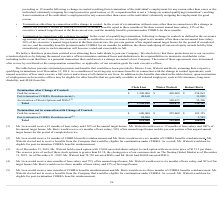From Marin Software's financial document, How many months of base salary would Mr Lien and Mr Walcott respectively receive as part of their cash severance? The document shows two values: 18 and 12. From the document: "(1) Mr. Lien would receive 18 months of base salary and 150% of his annual target bonus. Mr. Walcott would receive 12 months of b preceding or 12 mont..." Also, What percentage of their annual target bonus would Mr Lien and Mr Walcott respectively receive as part of their cash severance? The document shows two values: 150% and 100%. From the document: "Walcott would receive 12 months of base salary and 100% of his annual target bonus. Mr. Bertz would receive six months of base salary, 50% of his annu..." Also, How many months of COBRA benefits reimbursement would Mr Lien and Mr Bertz respectively receive as part of their post-termination COBRA Reimbursement? The document shows two values: 18 and 6. From the document: "(1) Mr. Lien would receive 18 months of base salary and 150% of his annual target bonus. Mr. Walcott would receive 12 months of b..." Also, can you calculate: What is the total cash severance paid by the company if they were to terminate Chris Lien, Mister Walcott and Robert Bertz after Change of Control? Based on the calculation: 254,063  + 450,000 + 1,200,000 , the result is 1904063. This is based on the information: "Cash Severance (1) $ 1,200,000 $ 450,000 $ 254,063 Cash Severance (1) $ 1,200,000 $ 450,000 $ 254,063 Cash Severance (1) $ 1,200,000 $ 450,000 $ 254,063..." The key data points involved are: 1,200,000, 254,063, 450,000. Also, can you calculate: What is the value of Wister Walcott's cash severance as a percentage of Chris Lien's under termination after Change of Control? Based on the calculation: 450,000/1,200,000 , the result is 37.5 (percentage). This is based on the information: "Cash Severance (1) $ 1,200,000 $ 450,000 $ 254,063 Cash Severance (1) $ 1,200,000 $ 450,000 $ 254,063..." The key data points involved are: 1,200,000, 450,000. Also, can you calculate: Under termination after Change of Control, what is the average value of Chris Lien's and Robert Bertz's post-termination COBRA Reimbursement? To answer this question, I need to perform calculations using the financial data. The calculation is: (48,160 +  11,098)/2 , which equals 29629. This is based on the information: "Post-termination COBRA Reimbursement (2) 48,160 — 11,098 Post-termination COBRA Reimbursement (2) 48,160 — 11,098..." The key data points involved are: 11,098, 48,160. 